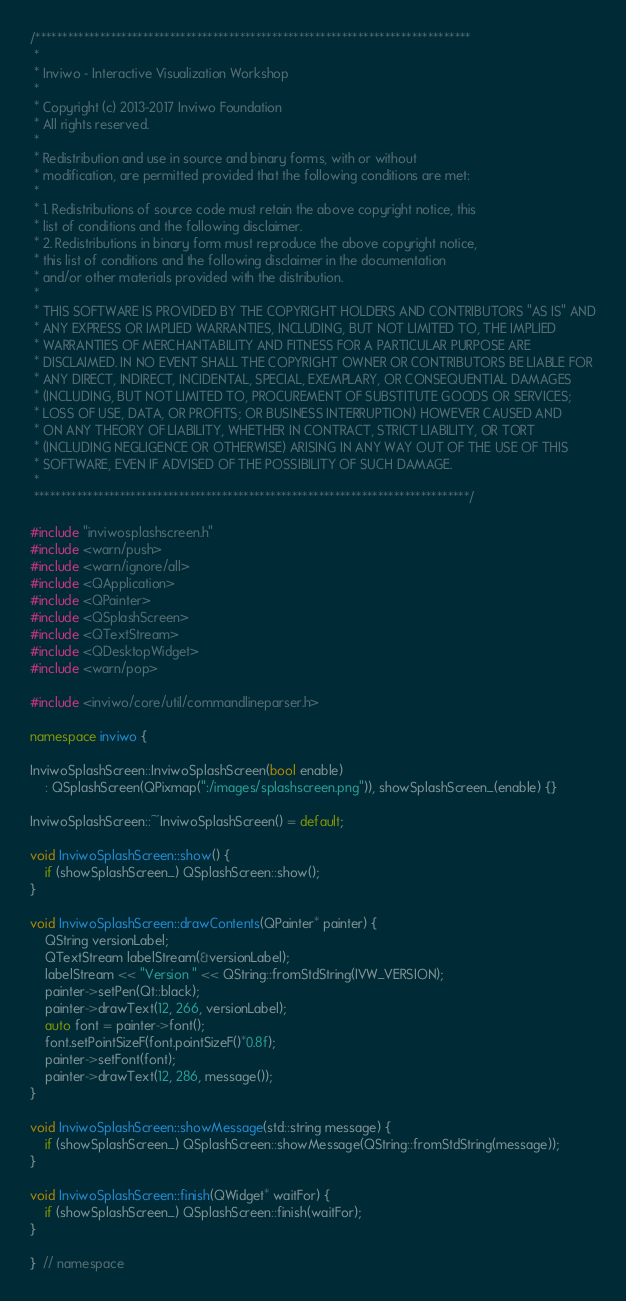Convert code to text. <code><loc_0><loc_0><loc_500><loc_500><_C++_>/*********************************************************************************
 *
 * Inviwo - Interactive Visualization Workshop
 *
 * Copyright (c) 2013-2017 Inviwo Foundation
 * All rights reserved.
 *
 * Redistribution and use in source and binary forms, with or without
 * modification, are permitted provided that the following conditions are met:
 *
 * 1. Redistributions of source code must retain the above copyright notice, this
 * list of conditions and the following disclaimer.
 * 2. Redistributions in binary form must reproduce the above copyright notice,
 * this list of conditions and the following disclaimer in the documentation
 * and/or other materials provided with the distribution.
 *
 * THIS SOFTWARE IS PROVIDED BY THE COPYRIGHT HOLDERS AND CONTRIBUTORS "AS IS" AND
 * ANY EXPRESS OR IMPLIED WARRANTIES, INCLUDING, BUT NOT LIMITED TO, THE IMPLIED
 * WARRANTIES OF MERCHANTABILITY AND FITNESS FOR A PARTICULAR PURPOSE ARE
 * DISCLAIMED. IN NO EVENT SHALL THE COPYRIGHT OWNER OR CONTRIBUTORS BE LIABLE FOR
 * ANY DIRECT, INDIRECT, INCIDENTAL, SPECIAL, EXEMPLARY, OR CONSEQUENTIAL DAMAGES
 * (INCLUDING, BUT NOT LIMITED TO, PROCUREMENT OF SUBSTITUTE GOODS OR SERVICES;
 * LOSS OF USE, DATA, OR PROFITS; OR BUSINESS INTERRUPTION) HOWEVER CAUSED AND
 * ON ANY THEORY OF LIABILITY, WHETHER IN CONTRACT, STRICT LIABILITY, OR TORT
 * (INCLUDING NEGLIGENCE OR OTHERWISE) ARISING IN ANY WAY OUT OF THE USE OF THIS
 * SOFTWARE, EVEN IF ADVISED OF THE POSSIBILITY OF SUCH DAMAGE.
 *
 *********************************************************************************/

#include "inviwosplashscreen.h"
#include <warn/push>
#include <warn/ignore/all>
#include <QApplication>
#include <QPainter>
#include <QSplashScreen>
#include <QTextStream>
#include <QDesktopWidget>
#include <warn/pop>

#include <inviwo/core/util/commandlineparser.h>

namespace inviwo {

InviwoSplashScreen::InviwoSplashScreen(bool enable)
    : QSplashScreen(QPixmap(":/images/splashscreen.png")), showSplashScreen_(enable) {}

InviwoSplashScreen::~InviwoSplashScreen() = default;

void InviwoSplashScreen::show() {
    if (showSplashScreen_) QSplashScreen::show();
}

void InviwoSplashScreen::drawContents(QPainter* painter) {
    QString versionLabel;
    QTextStream labelStream(&versionLabel);
    labelStream << "Version " << QString::fromStdString(IVW_VERSION);
    painter->setPen(Qt::black);
    painter->drawText(12, 266, versionLabel);
    auto font = painter->font();
    font.setPointSizeF(font.pointSizeF()*0.8f);
    painter->setFont(font);
    painter->drawText(12, 286, message());
}

void InviwoSplashScreen::showMessage(std::string message) {
    if (showSplashScreen_) QSplashScreen::showMessage(QString::fromStdString(message));
}

void InviwoSplashScreen::finish(QWidget* waitFor) {
    if (showSplashScreen_) QSplashScreen::finish(waitFor);
}

}  // namespace</code> 